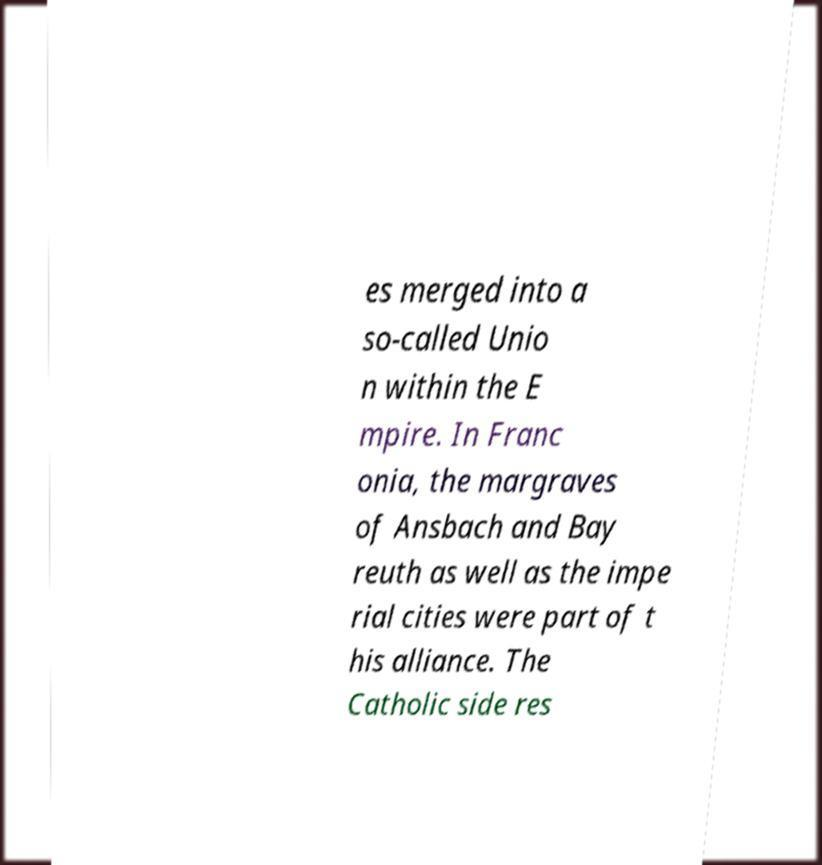What messages or text are displayed in this image? I need them in a readable, typed format. es merged into a so-called Unio n within the E mpire. In Franc onia, the margraves of Ansbach and Bay reuth as well as the impe rial cities were part of t his alliance. The Catholic side res 